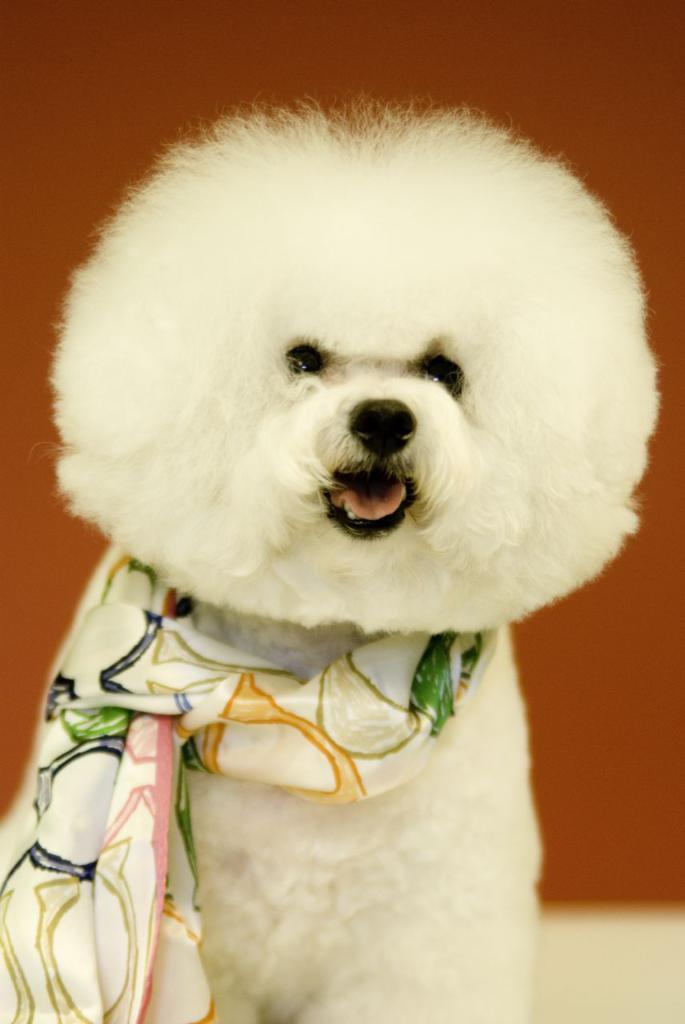What type of animal is in the picture? There is a dog in the picture. What is the dog wearing? The dog is wearing a scarf. Can you describe the background of the image? The background of the image is blurred. What color is the blood on the dog's scarf in the image? There is no blood present in the image; the dog is wearing a scarf, but there is no mention of blood. 